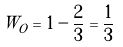Convert formula to latex. <formula><loc_0><loc_0><loc_500><loc_500>W _ { O } = 1 - \frac { 2 } { 3 } = \frac { 1 } { 3 }</formula> 